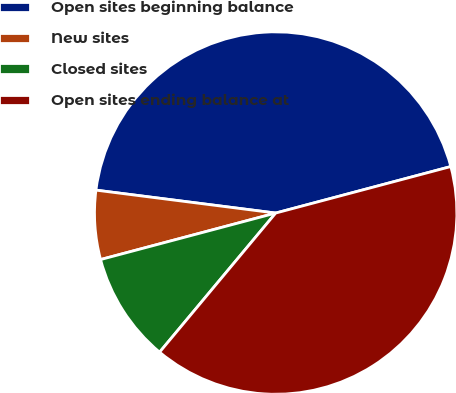<chart> <loc_0><loc_0><loc_500><loc_500><pie_chart><fcel>Open sites beginning balance<fcel>New sites<fcel>Closed sites<fcel>Open sites ending balance at<nl><fcel>43.85%<fcel>6.15%<fcel>9.8%<fcel>40.2%<nl></chart> 